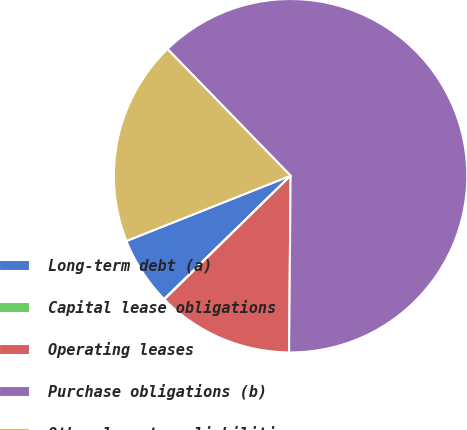Convert chart. <chart><loc_0><loc_0><loc_500><loc_500><pie_chart><fcel>Long-term debt (a)<fcel>Capital lease obligations<fcel>Operating leases<fcel>Purchase obligations (b)<fcel>Other long-term liabilities<nl><fcel>6.28%<fcel>0.04%<fcel>12.52%<fcel>62.41%<fcel>18.75%<nl></chart> 